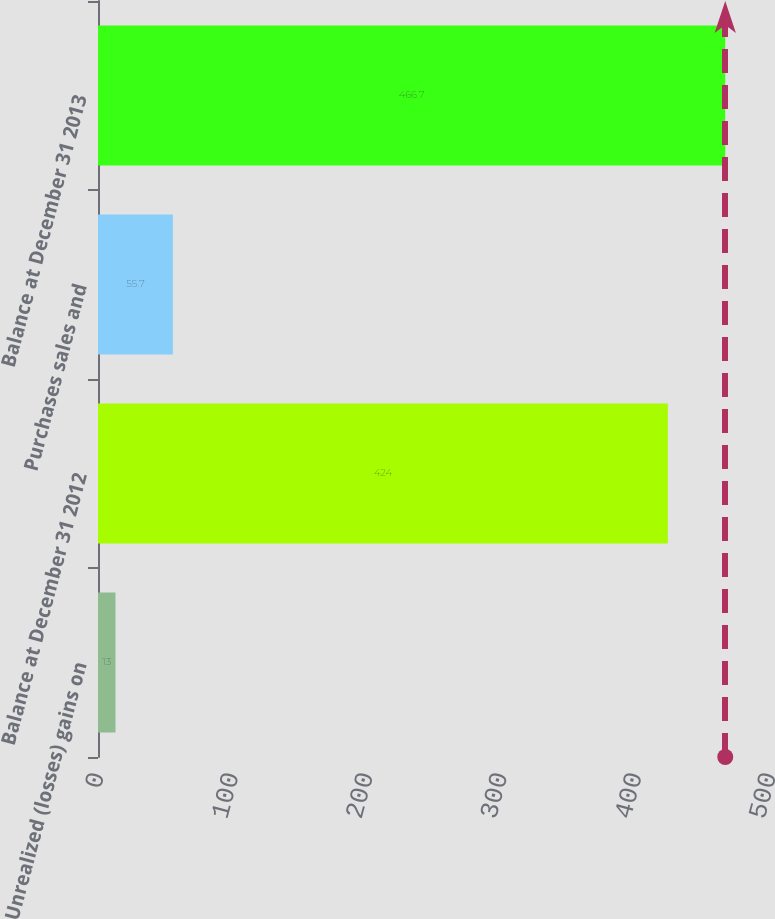Convert chart to OTSL. <chart><loc_0><loc_0><loc_500><loc_500><bar_chart><fcel>Unrealized (losses) gains on<fcel>Balance at December 31 2012<fcel>Purchases sales and<fcel>Balance at December 31 2013<nl><fcel>13<fcel>424<fcel>55.7<fcel>466.7<nl></chart> 